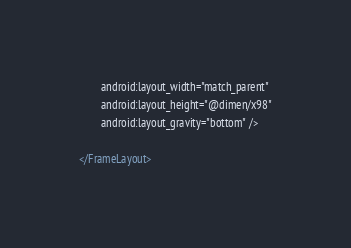Convert code to text. <code><loc_0><loc_0><loc_500><loc_500><_XML_>        android:layout_width="match_parent"
        android:layout_height="@dimen/x98"
        android:layout_gravity="bottom" />

</FrameLayout></code> 